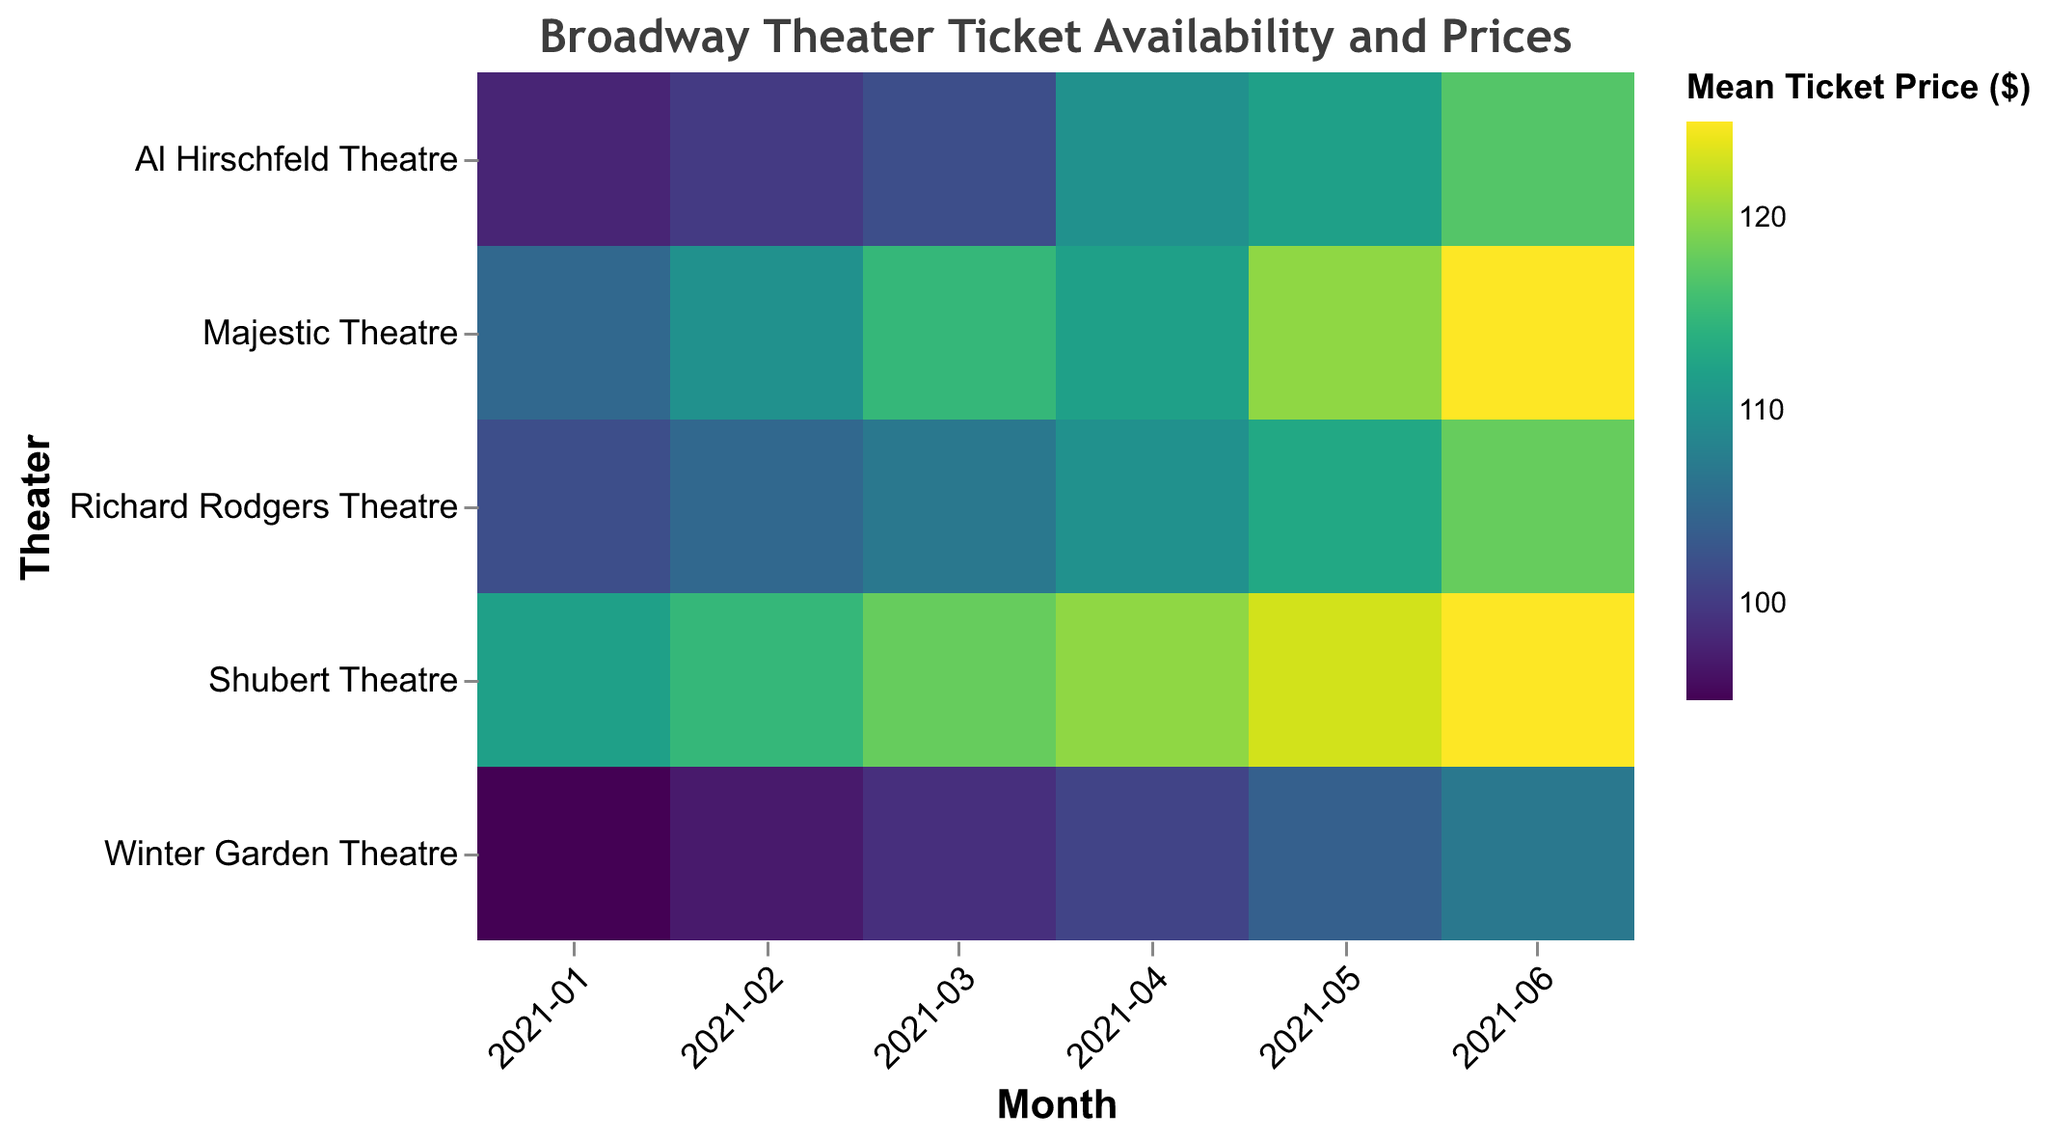How does the ticket availability at Majestic Theatre in January compare to June? The heatmap indicates the mean ticket availability percentage by color intensity. Referring to the figure, January's availability at Majestic Theatre is 53%, while June's is 68%. Hence, ticket availability increased from January to June.
Answer: Ticket availability increased What is the highest mean ticket price recorded across all theaters and months? Checking the color key and the corresponding color intensity in the figure, the highest mean ticket price is recorded at Majestic Theatre in June, at $125.
Answer: $125 Which theater had the lowest mean ticket price in January 2021? By referring to the color legend and intensity at January 2021, Winter Garden Theatre had the lowest mean ticket price which was $95.
Answer: Winter Garden Theatre Did any theater have a decreasing trend in mean ticket availability from January to June? By analyzing the trends in each theater row sequentially from January to June, it is observed that all theaters have an increasing trend, with no decreasing trend in mean ticket availability.
Answer: No What is the average mean ticket price for Richard Rodgers Theatre from January to June 2021? Sum the mean ticket prices for Richard Rodgers Theatre from January to June and divide by the number of months, i.e., (102 + 105 + 107 + 110 + 113 + 118) / 6 = 655 / 6 ≈ 109.17.
Answer: $109.17 Which month shows the highest overall mean ticket availability across all theaters? Check the colors and values for mean ticket availability for each month across all theaters. June consistently shows the highest availability percentage in each theater.
Answer: June How does the mean ticket price at Al Hirschfeld Theatre in February compare to that in May 2021? By referring to the figure, the mean ticket prices are $100 in February and $112 in May. The price increased by $12.
Answer: Increased by $12 Is there any month where two theaters had the same mean ticket price? Examine the color intensities and associated values; April 2021 has two theaters (Majestic Theatre and Richard Rodgers Theatre) with a mean ticket price of $110.
Answer: Yes, April 2021 Which theater had the most significant increase in mean ticket availability from January to June 2021? Calculate the increase for each theater and compare; Majestic Theatre had the highest increase (68% - 53% = 15%).
Answer: Majestic Theatre During which month and in which theater was the mean ticket price $123? Check each month and theater in the heatmap for the value $123; found in Shubert Theatre during May 2021.
Answer: May 2021, Shubert Theatre 